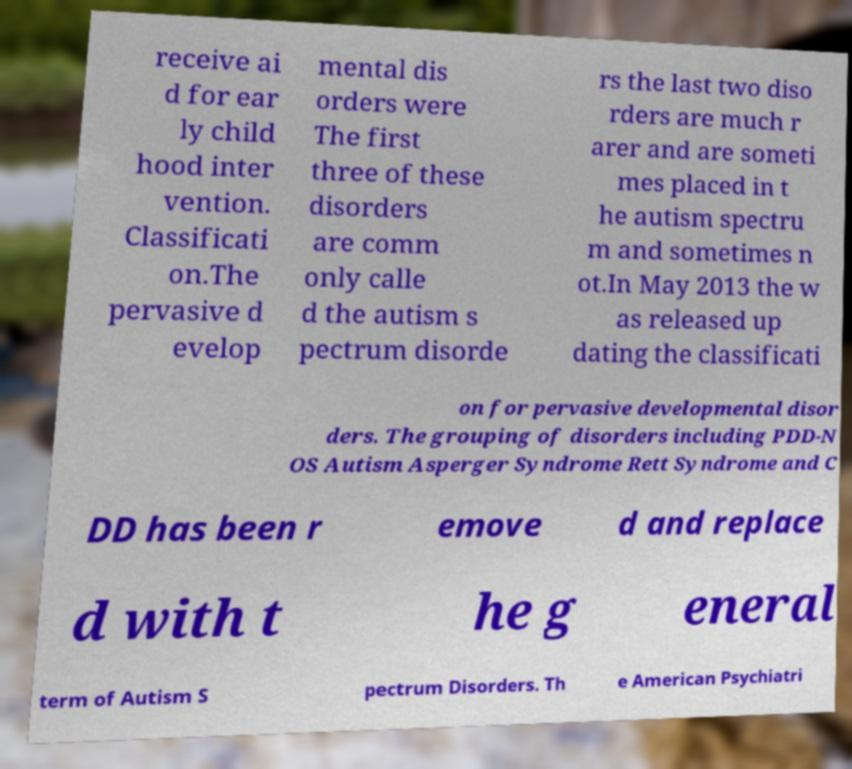There's text embedded in this image that I need extracted. Can you transcribe it verbatim? receive ai d for ear ly child hood inter vention. Classificati on.The pervasive d evelop mental dis orders were The first three of these disorders are comm only calle d the autism s pectrum disorde rs the last two diso rders are much r arer and are someti mes placed in t he autism spectru m and sometimes n ot.In May 2013 the w as released up dating the classificati on for pervasive developmental disor ders. The grouping of disorders including PDD-N OS Autism Asperger Syndrome Rett Syndrome and C DD has been r emove d and replace d with t he g eneral term of Autism S pectrum Disorders. Th e American Psychiatri 